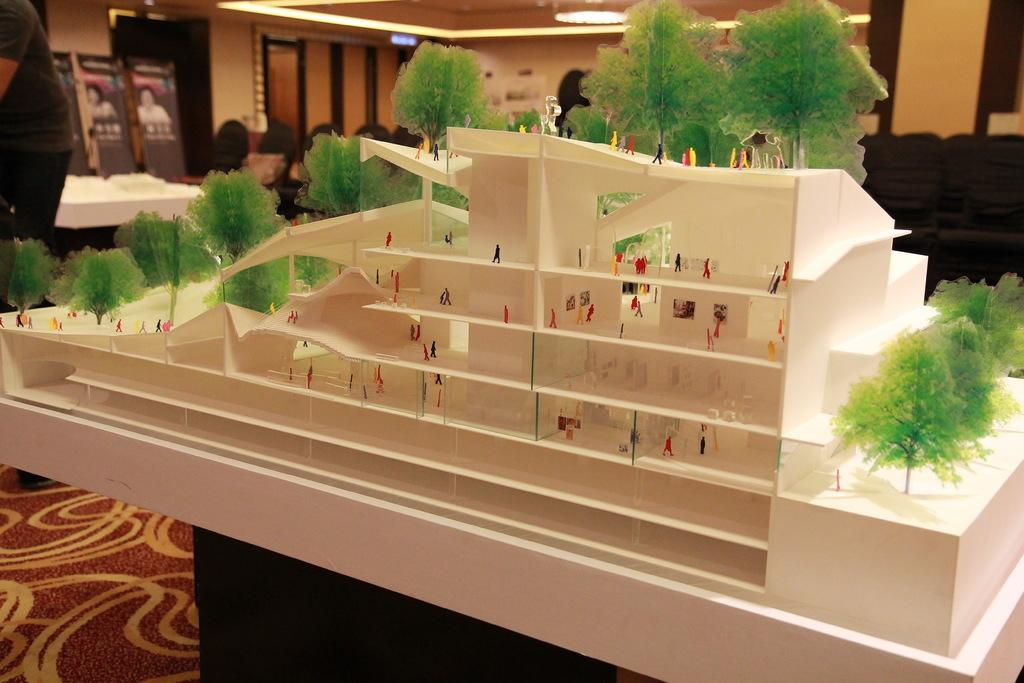Who or what can be seen in the image? There are people in the image. What else is present in the image besides the people? There is a miniature in the image. What can be observed in the background of the image? There are lights, tables, and frames in the background of the image. How many sheep are visible in the image? There are no sheep present in the image. What type of crook can be seen in the hands of the people in the image? There is no crook present in the image; the people are not holding any such object. 